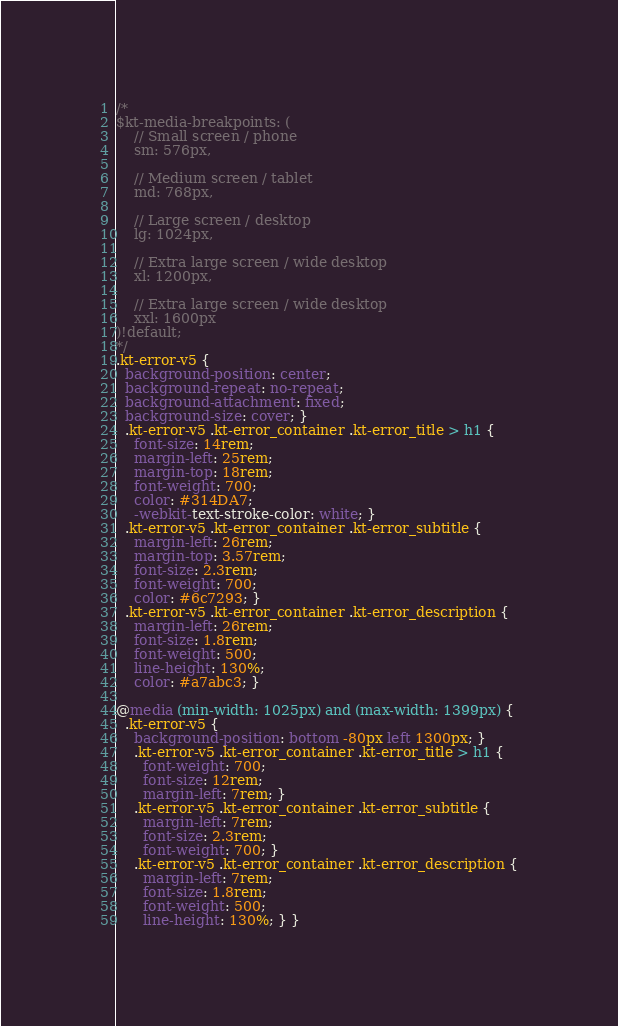<code> <loc_0><loc_0><loc_500><loc_500><_CSS_>/*
$kt-media-breakpoints: (
    // Small screen / phone
    sm: 576px,
    
    // Medium screen / tablet
    md: 768px,
    
    // Large screen / desktop
    lg: 1024px,
    
    // Extra large screen / wide desktop
    xl: 1200px,

    // Extra large screen / wide desktop
    xxl: 1600px
)!default;
*/
.kt-error-v5 {
  background-position: center;
  background-repeat: no-repeat;
  background-attachment: fixed;
  background-size: cover; }
  .kt-error-v5 .kt-error_container .kt-error_title > h1 {
    font-size: 14rem;
    margin-left: 25rem;
    margin-top: 18rem;
    font-weight: 700;
    color: #314DA7;
    -webkit-text-stroke-color: white; }
  .kt-error-v5 .kt-error_container .kt-error_subtitle {
    margin-left: 26rem;
    margin-top: 3.57rem;
    font-size: 2.3rem;
    font-weight: 700;
    color: #6c7293; }
  .kt-error-v5 .kt-error_container .kt-error_description {
    margin-left: 26rem;
    font-size: 1.8rem;
    font-weight: 500;
    line-height: 130%;
    color: #a7abc3; }

@media (min-width: 1025px) and (max-width: 1399px) {
  .kt-error-v5 {
    background-position: bottom -80px left 1300px; }
    .kt-error-v5 .kt-error_container .kt-error_title > h1 {
      font-weight: 700;
      font-size: 12rem;
      margin-left: 7rem; }
    .kt-error-v5 .kt-error_container .kt-error_subtitle {
      margin-left: 7rem;
      font-size: 2.3rem;
      font-weight: 700; }
    .kt-error-v5 .kt-error_container .kt-error_description {
      margin-left: 7rem;
      font-size: 1.8rem;
      font-weight: 500;
      line-height: 130%; } }
</code> 